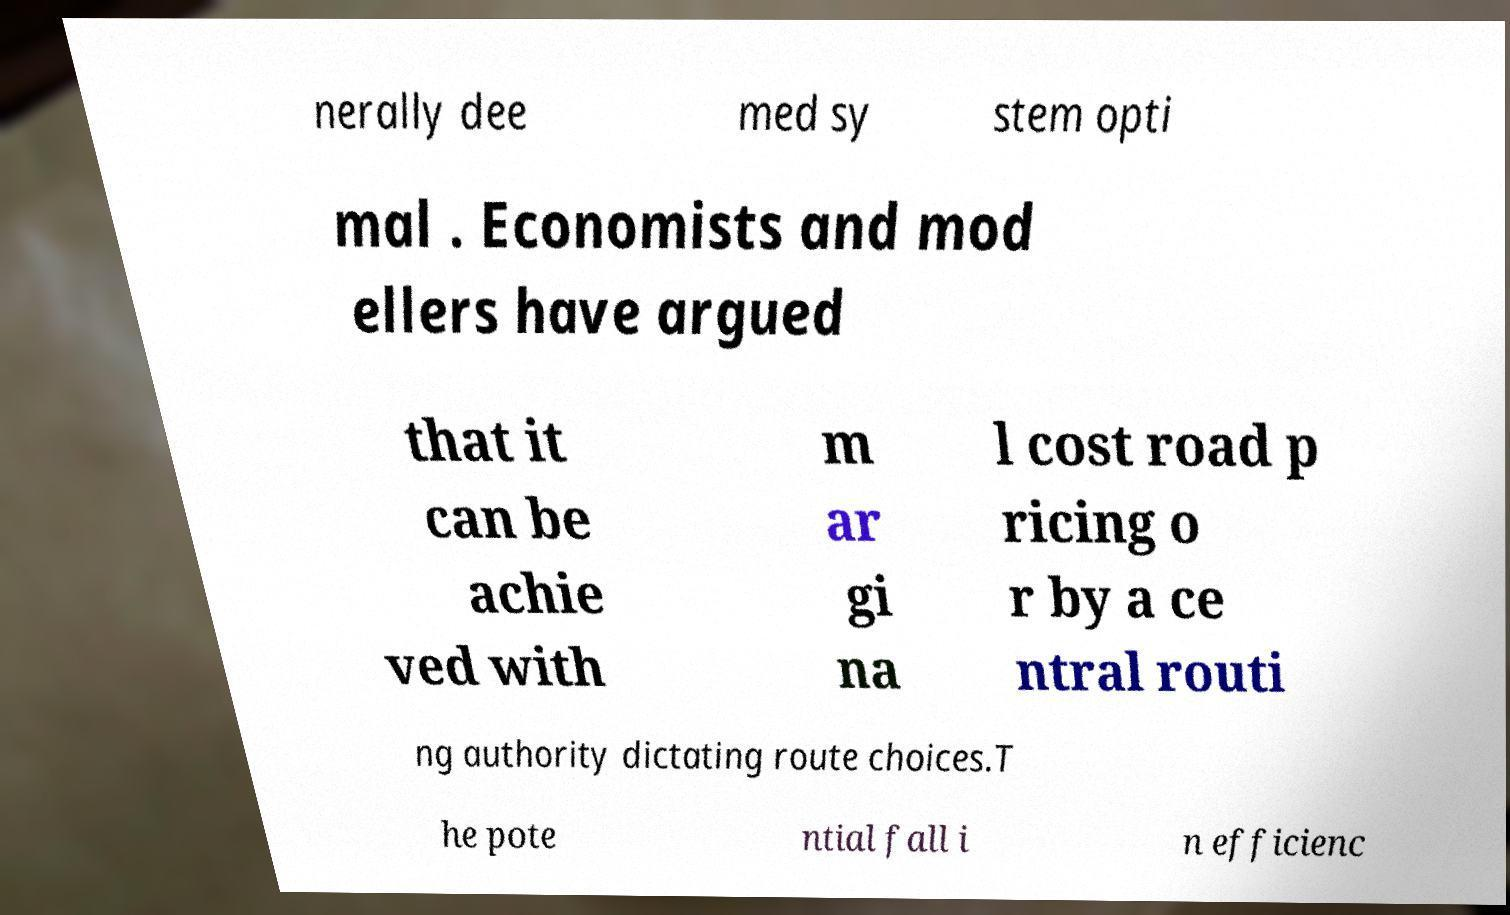Please read and relay the text visible in this image. What does it say? nerally dee med sy stem opti mal . Economists and mod ellers have argued that it can be achie ved with m ar gi na l cost road p ricing o r by a ce ntral routi ng authority dictating route choices.T he pote ntial fall i n efficienc 